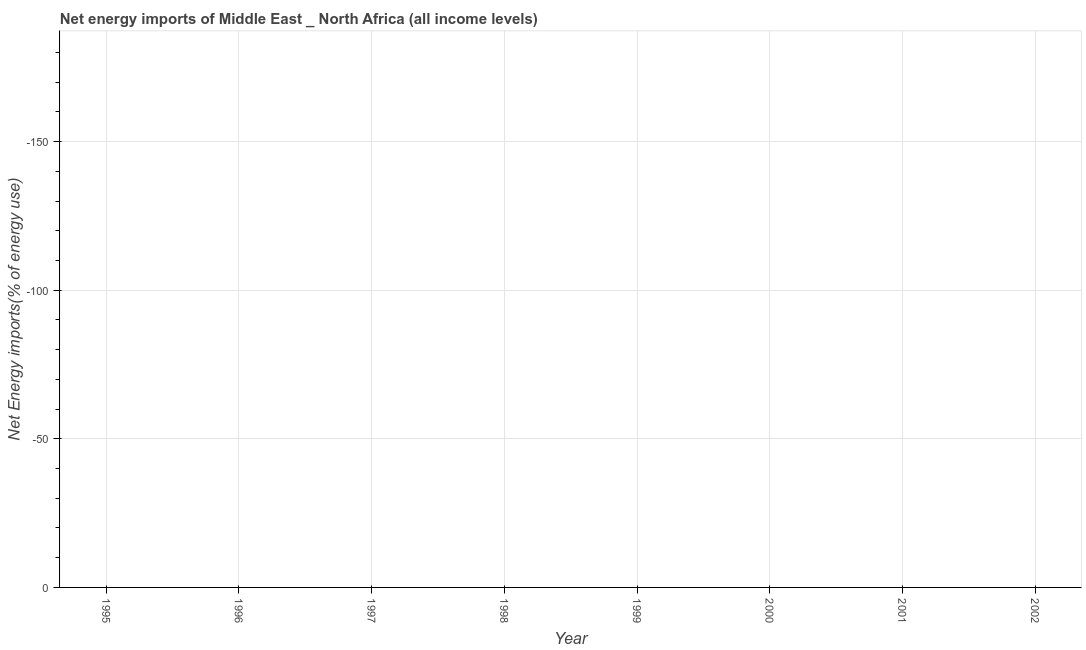Across all years, what is the minimum energy imports?
Offer a terse response. 0. What is the median energy imports?
Ensure brevity in your answer.  0. In how many years, is the energy imports greater than -110 %?
Your answer should be compact. 0. In how many years, is the energy imports greater than the average energy imports taken over all years?
Ensure brevity in your answer.  0. Does the energy imports monotonically increase over the years?
Give a very brief answer. No. What is the difference between two consecutive major ticks on the Y-axis?
Make the answer very short. 50. Are the values on the major ticks of Y-axis written in scientific E-notation?
Your answer should be very brief. No. Does the graph contain grids?
Give a very brief answer. Yes. What is the title of the graph?
Give a very brief answer. Net energy imports of Middle East _ North Africa (all income levels). What is the label or title of the X-axis?
Ensure brevity in your answer.  Year. What is the label or title of the Y-axis?
Your response must be concise. Net Energy imports(% of energy use). What is the Net Energy imports(% of energy use) in 1995?
Ensure brevity in your answer.  0. What is the Net Energy imports(% of energy use) of 1996?
Offer a very short reply. 0. What is the Net Energy imports(% of energy use) in 1997?
Provide a short and direct response. 0. What is the Net Energy imports(% of energy use) in 1999?
Ensure brevity in your answer.  0. What is the Net Energy imports(% of energy use) of 2000?
Offer a terse response. 0. What is the Net Energy imports(% of energy use) of 2001?
Make the answer very short. 0. What is the Net Energy imports(% of energy use) in 2002?
Give a very brief answer. 0. 